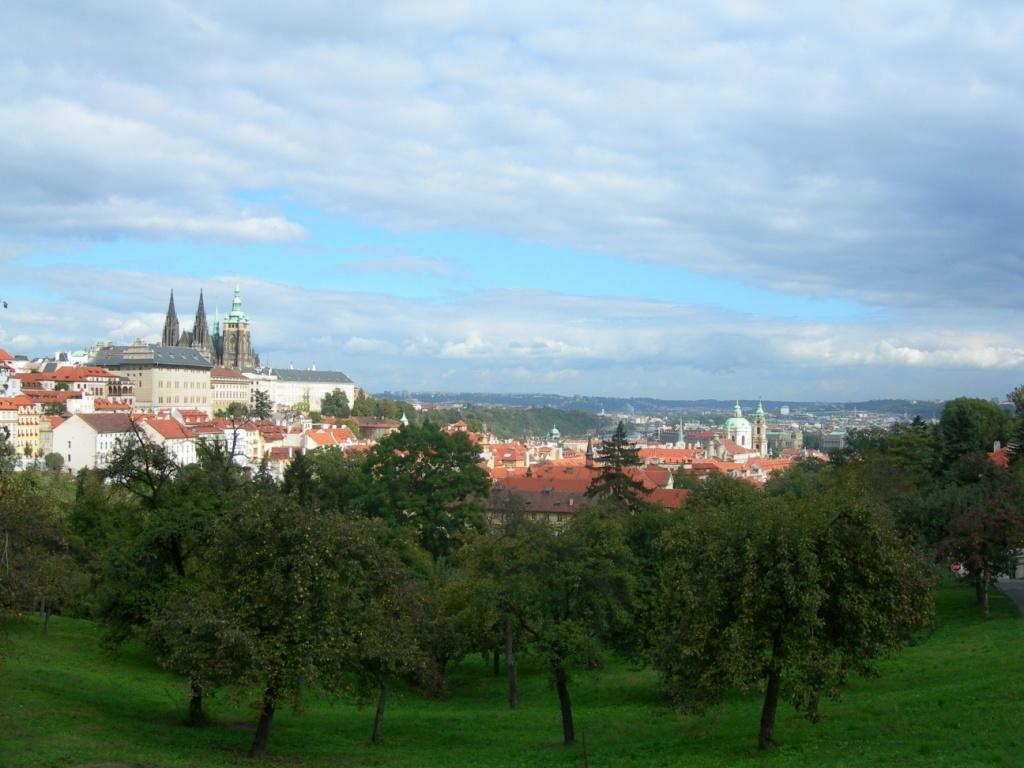Can you describe this image briefly? This is the picture of a city. In this image there are buildings and trees. At the top there is sky and there are clouds. At the bottom there is grass. 